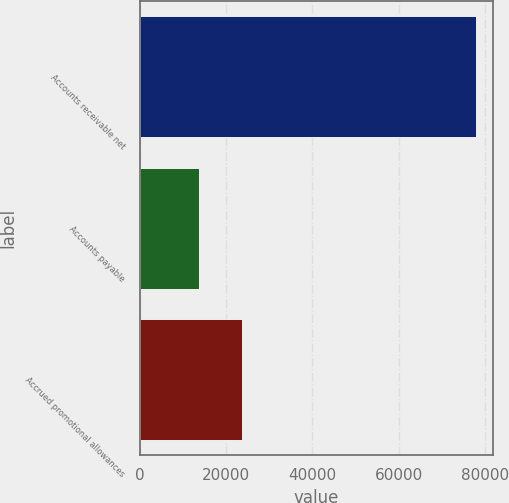Convert chart to OTSL. <chart><loc_0><loc_0><loc_500><loc_500><bar_chart><fcel>Accounts receivable net<fcel>Accounts payable<fcel>Accrued promotional allowances<nl><fcel>78011<fcel>13738<fcel>23776<nl></chart> 